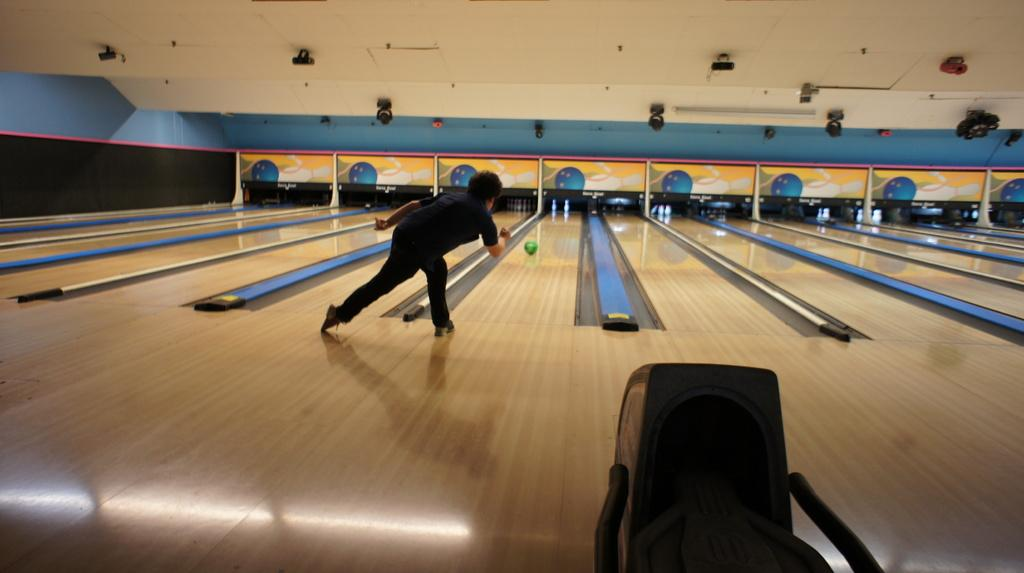What is the person in the image doing? The person in the image is playing ball. What can be seen at the bottom of the image? A stand is present at the bottom of the image. What color is the roof in the image? The roof is white in color. What material is the floor made of? The floor is furnished with wood. Can you tell me how many nails the doctor is holding in the image? There is no doctor or nails present in the image. 